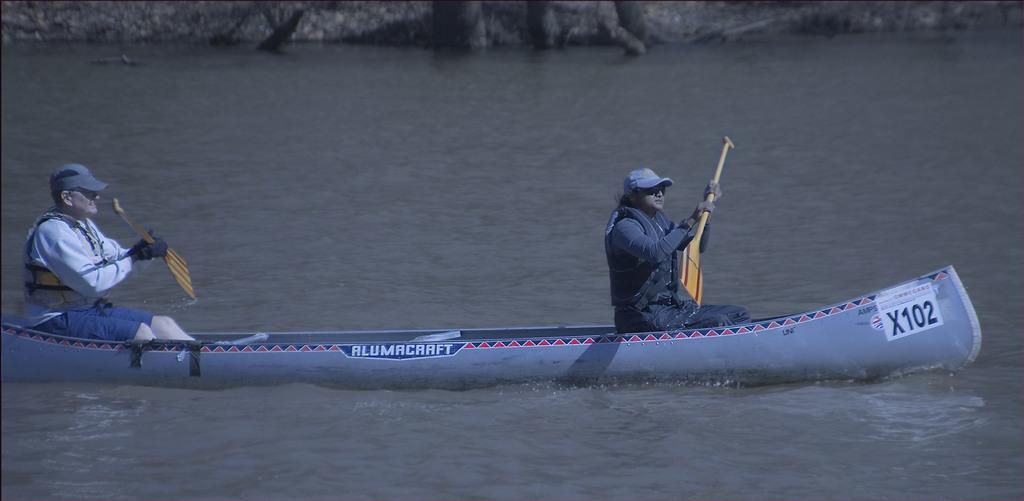Can you describe this image briefly? There are two persons in different color dresses, holding wooden objects and sitting on a boat. This boat is on the water. 